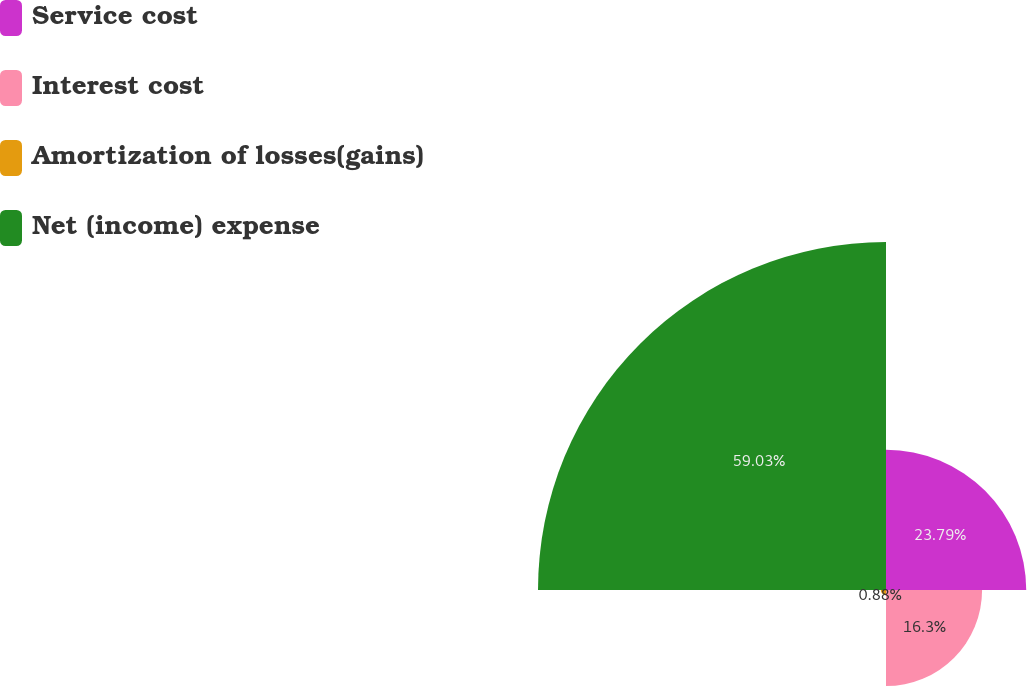Convert chart to OTSL. <chart><loc_0><loc_0><loc_500><loc_500><pie_chart><fcel>Service cost<fcel>Interest cost<fcel>Amortization of losses(gains)<fcel>Net (income) expense<nl><fcel>23.79%<fcel>16.3%<fcel>0.88%<fcel>59.03%<nl></chart> 